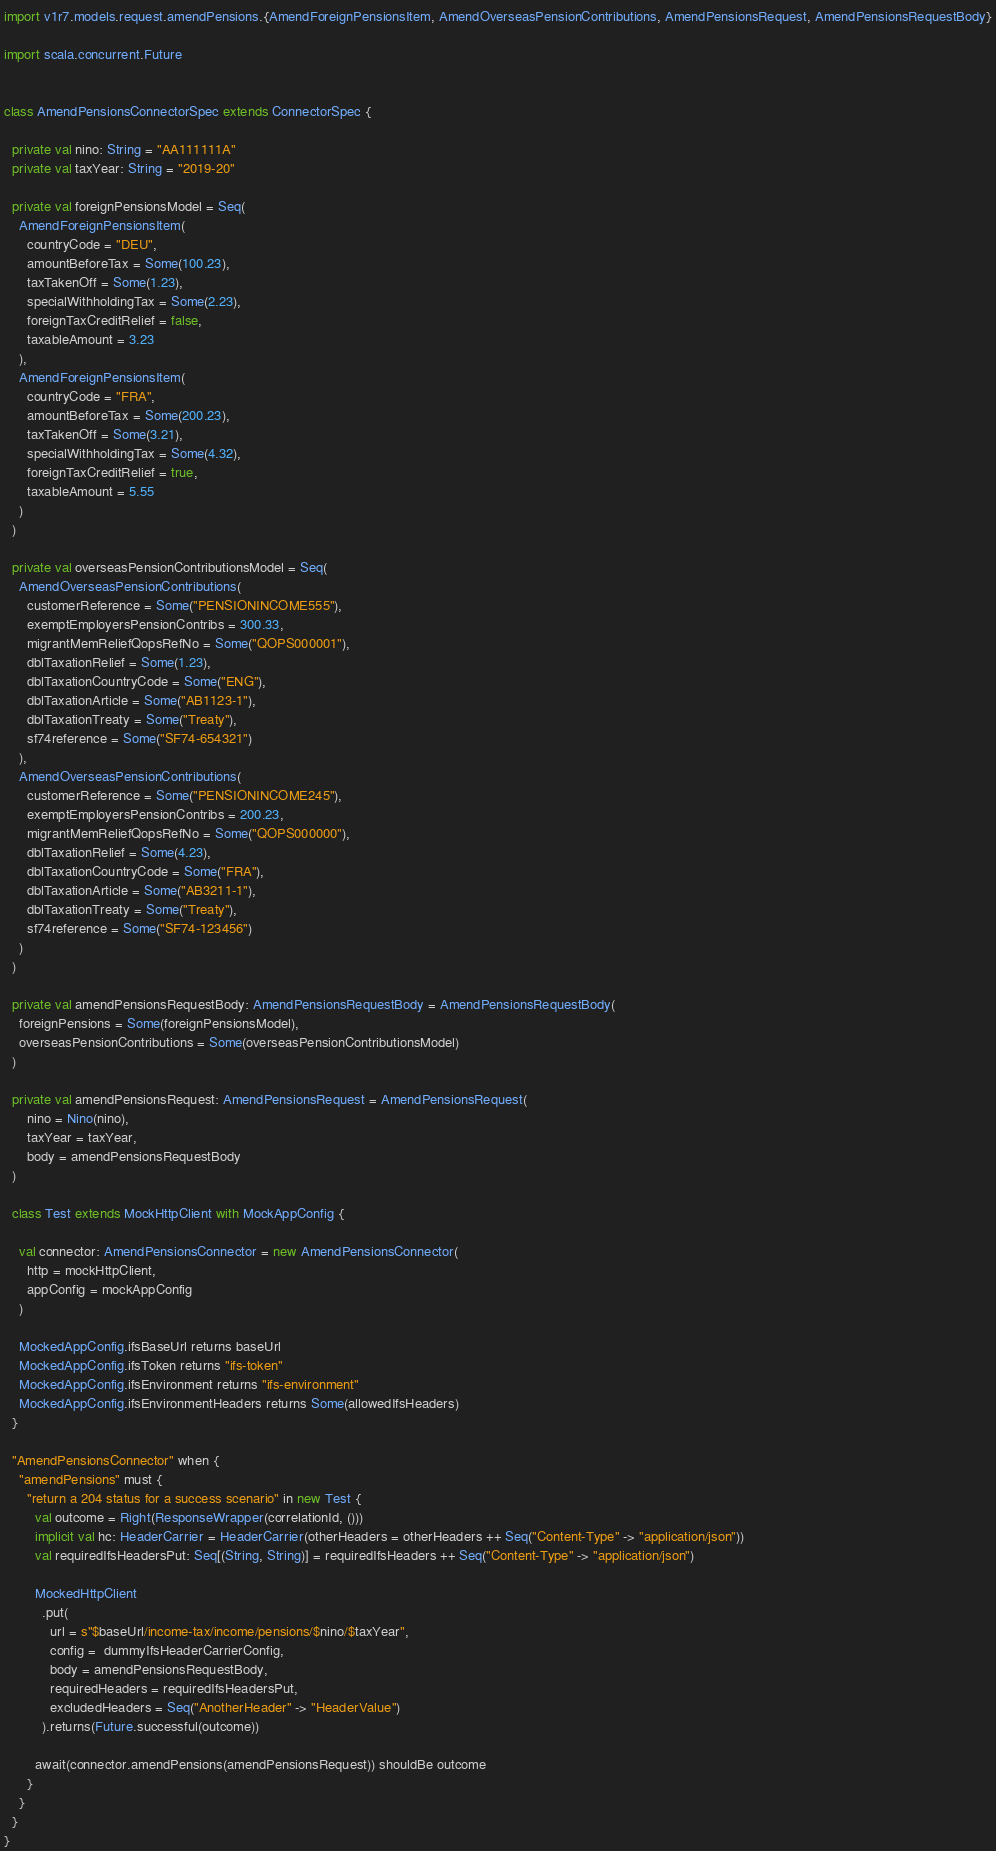Convert code to text. <code><loc_0><loc_0><loc_500><loc_500><_Scala_>import v1r7.models.request.amendPensions.{AmendForeignPensionsItem, AmendOverseasPensionContributions, AmendPensionsRequest, AmendPensionsRequestBody}

import scala.concurrent.Future


class AmendPensionsConnectorSpec extends ConnectorSpec {

  private val nino: String = "AA111111A"
  private val taxYear: String = "2019-20"

  private val foreignPensionsModel = Seq(
    AmendForeignPensionsItem(
      countryCode = "DEU",
      amountBeforeTax = Some(100.23),
      taxTakenOff = Some(1.23),
      specialWithholdingTax = Some(2.23),
      foreignTaxCreditRelief = false,
      taxableAmount = 3.23
    ),
    AmendForeignPensionsItem(
      countryCode = "FRA",
      amountBeforeTax = Some(200.23),
      taxTakenOff = Some(3.21),
      specialWithholdingTax = Some(4.32),
      foreignTaxCreditRelief = true,
      taxableAmount = 5.55
    )
  )

  private val overseasPensionContributionsModel = Seq(
    AmendOverseasPensionContributions(
      customerReference = Some("PENSIONINCOME555"),
      exemptEmployersPensionContribs = 300.33,
      migrantMemReliefQopsRefNo = Some("QOPS000001"),
      dblTaxationRelief = Some(1.23),
      dblTaxationCountryCode = Some("ENG"),
      dblTaxationArticle = Some("AB1123-1"),
      dblTaxationTreaty = Some("Treaty"),
      sf74reference = Some("SF74-654321")
    ),
    AmendOverseasPensionContributions(
      customerReference = Some("PENSIONINCOME245"),
      exemptEmployersPensionContribs = 200.23,
      migrantMemReliefQopsRefNo = Some("QOPS000000"),
      dblTaxationRelief = Some(4.23),
      dblTaxationCountryCode = Some("FRA"),
      dblTaxationArticle = Some("AB3211-1"),
      dblTaxationTreaty = Some("Treaty"),
      sf74reference = Some("SF74-123456")
    )
  )

  private val amendPensionsRequestBody: AmendPensionsRequestBody = AmendPensionsRequestBody(
    foreignPensions = Some(foreignPensionsModel),
    overseasPensionContributions = Some(overseasPensionContributionsModel)
  )

  private val amendPensionsRequest: AmendPensionsRequest = AmendPensionsRequest(
      nino = Nino(nino),
      taxYear = taxYear,
      body = amendPensionsRequestBody
  )

  class Test extends MockHttpClient with MockAppConfig {

    val connector: AmendPensionsConnector = new AmendPensionsConnector(
      http = mockHttpClient,
      appConfig = mockAppConfig
    )

    MockedAppConfig.ifsBaseUrl returns baseUrl
    MockedAppConfig.ifsToken returns "ifs-token"
    MockedAppConfig.ifsEnvironment returns "ifs-environment"
    MockedAppConfig.ifsEnvironmentHeaders returns Some(allowedIfsHeaders)
  }

  "AmendPensionsConnector" when {
    "amendPensions" must {
      "return a 204 status for a success scenario" in new Test {
        val outcome = Right(ResponseWrapper(correlationId, ()))
        implicit val hc: HeaderCarrier = HeaderCarrier(otherHeaders = otherHeaders ++ Seq("Content-Type" -> "application/json"))
        val requiredIfsHeadersPut: Seq[(String, String)] = requiredIfsHeaders ++ Seq("Content-Type" -> "application/json")

        MockedHttpClient
          .put(
            url = s"$baseUrl/income-tax/income/pensions/$nino/$taxYear",
            config =  dummyIfsHeaderCarrierConfig,
            body = amendPensionsRequestBody,
            requiredHeaders = requiredIfsHeadersPut,
            excludedHeaders = Seq("AnotherHeader" -> "HeaderValue")
          ).returns(Future.successful(outcome))

        await(connector.amendPensions(amendPensionsRequest)) shouldBe outcome
      }
    }
  }
}</code> 